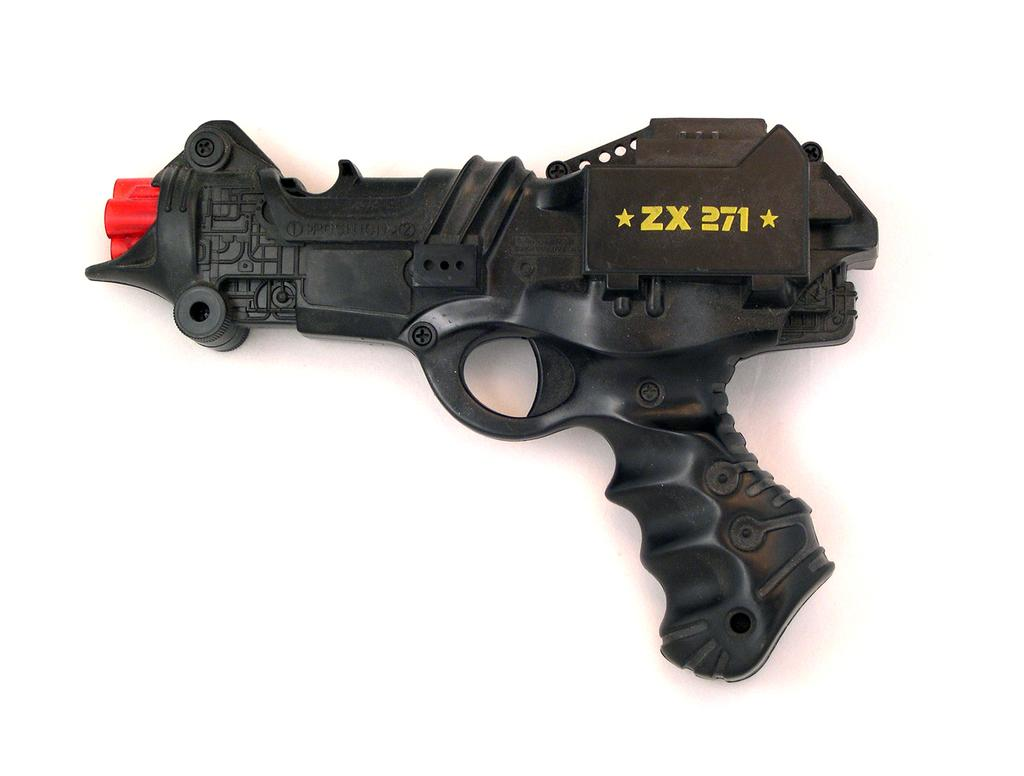What type of toy is present in the image? There is a toy gun in the image. What color is the toy gun? The toy gun is black in color. Is there any text or markings on the toy gun? Yes, "ZX 271" is written on the toy gun. Where is the church located in the image? There is no church present in the image. What type of cup is being used to hold the knot in the image? There is no cup or knot present in the image. 